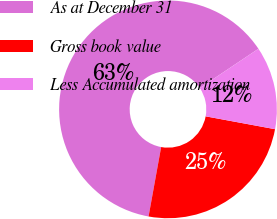Convert chart to OTSL. <chart><loc_0><loc_0><loc_500><loc_500><pie_chart><fcel>As at December 31<fcel>Gross book value<fcel>Less Accumulated amortization<nl><fcel>62.75%<fcel>24.94%<fcel>12.31%<nl></chart> 